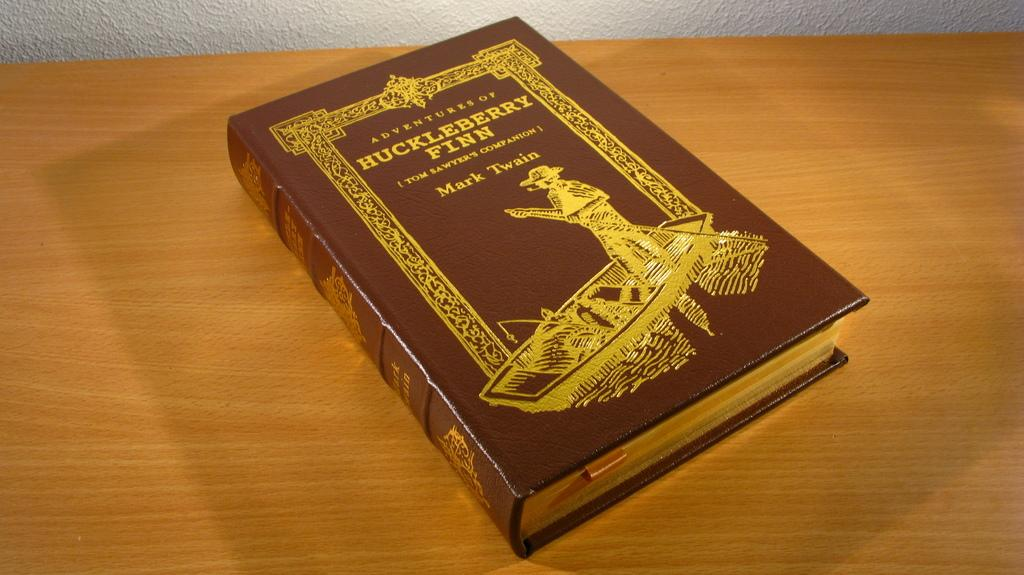<image>
Present a compact description of the photo's key features. An Adventures of Huckleberry Finn book sits on a wooden table. 